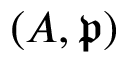Convert formula to latex. <formula><loc_0><loc_0><loc_500><loc_500>( A , { \mathfrak { p } } )</formula> 